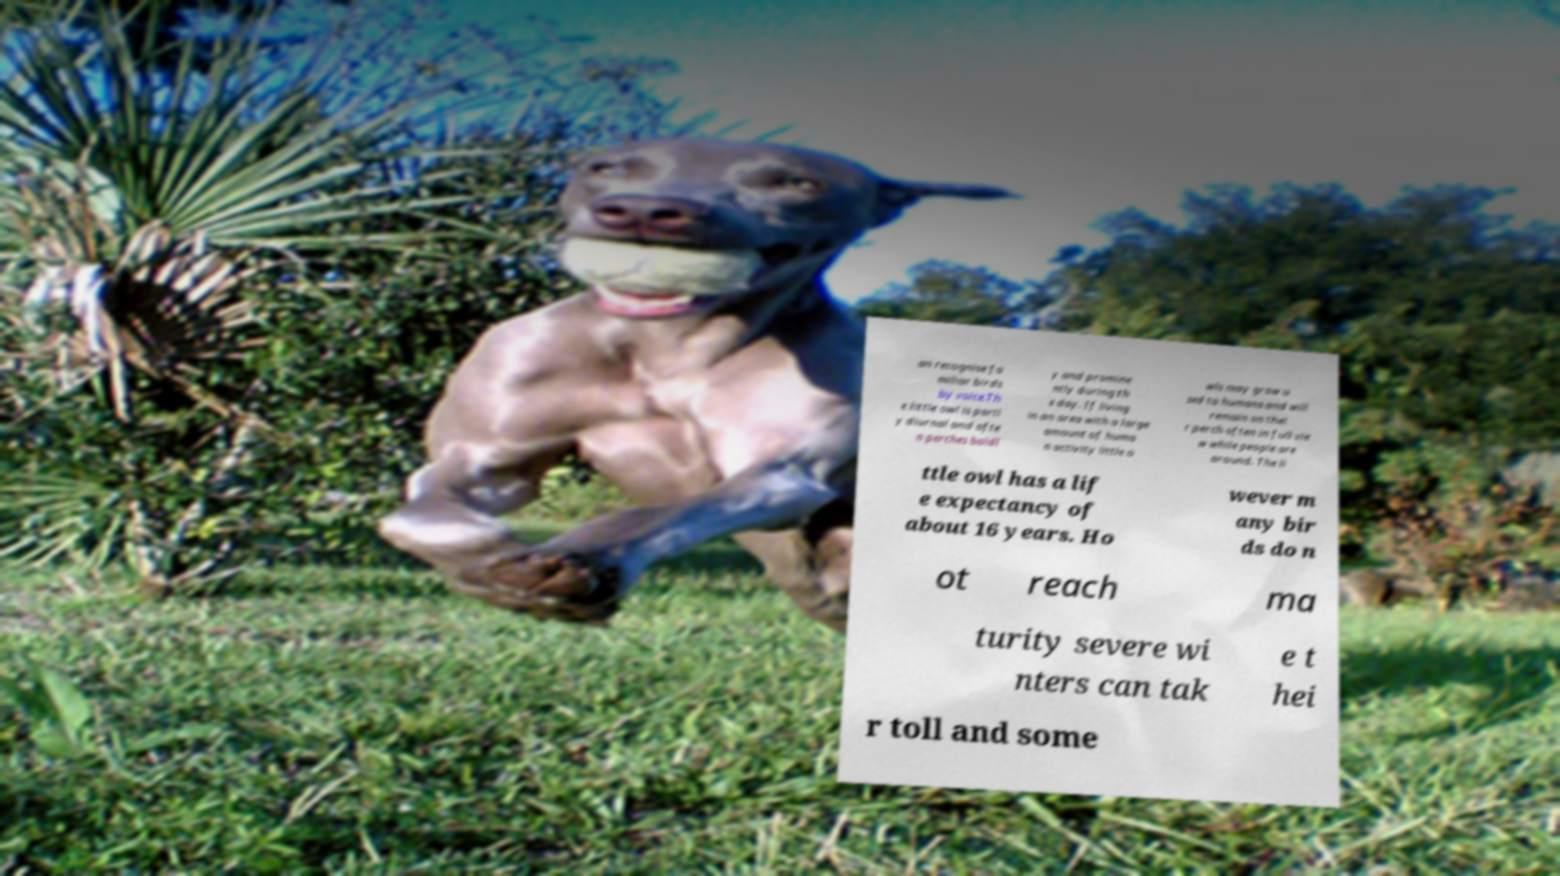Could you assist in decoding the text presented in this image and type it out clearly? an recognise fa miliar birds by voice.Th e little owl is partl y diurnal and ofte n perches boldl y and promine ntly during th e day. If living in an area with a large amount of huma n activity little o wls may grow u sed to humans and will remain on thei r perch often in full vie w while people are around. The li ttle owl has a lif e expectancy of about 16 years. Ho wever m any bir ds do n ot reach ma turity severe wi nters can tak e t hei r toll and some 